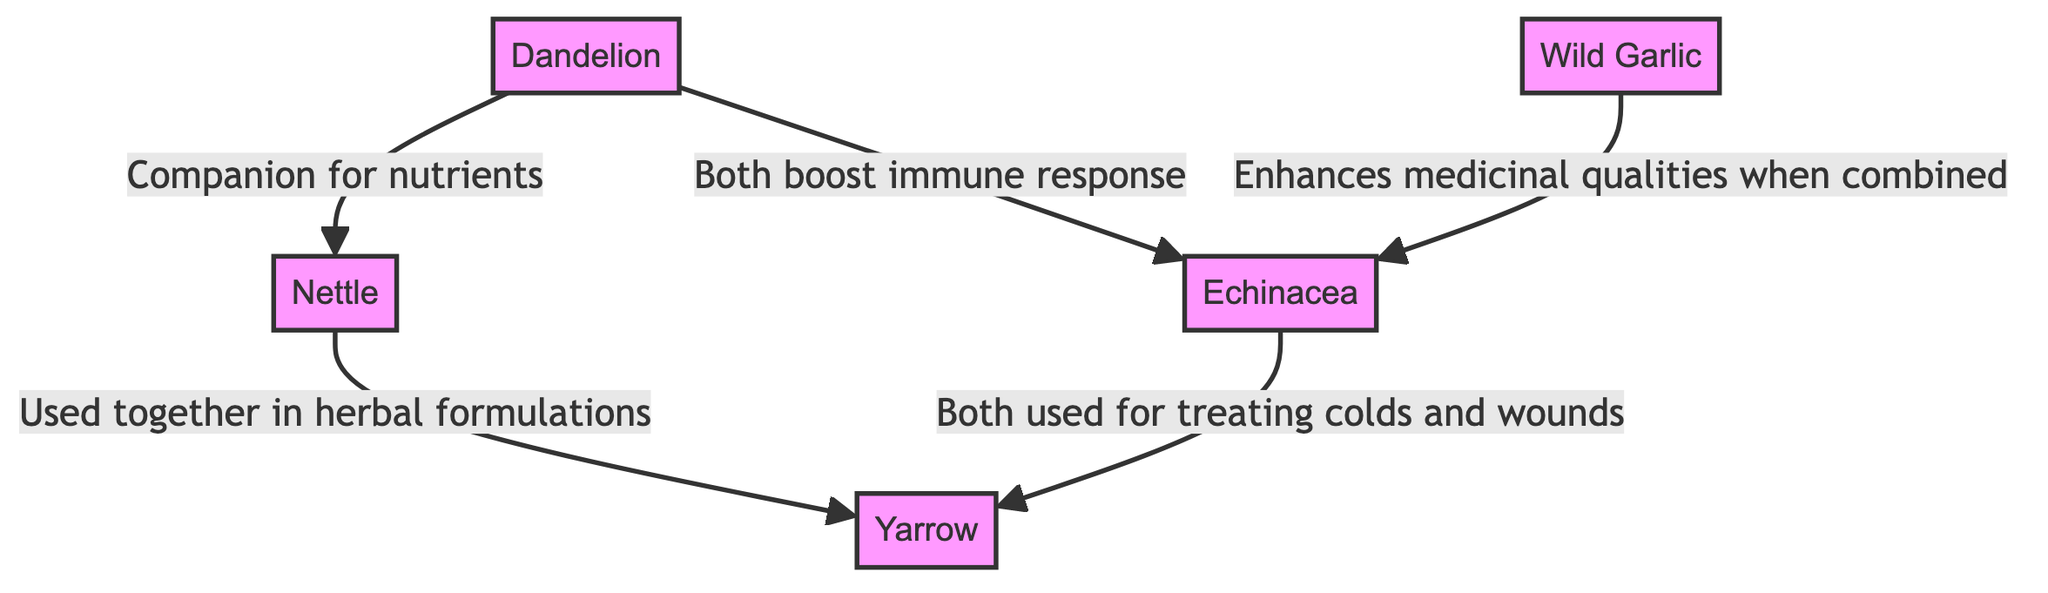What is the total number of nodes in the diagram? The diagram lists five distinct wild edibles: Dandelion, Nettle, Echinacea, Yarrow, and Wild Garlic. Counting these, the total number of nodes is 5.
Answer: 5 What is the relationship between Dandelion and Nettle? The diagram indicates that Dandelion is a companion for Nettle, specifically stating, "Companion for nutrients and soil health." This clarifies their relationship directly as described in the directed graph.
Answer: Companion for nutrients and soil health Which two plants are used together in herbal formulations? According to the diagram, Nettle and Yarrow are indicated to be used together in herbal formulations, as specified by the edge connecting them.
Answer: Nettle and Yarrow How many edges connect to Echinacea? By examining the directed edges, Echinacea connects to Yarrow and Wild Garlic, which totals to two edges leading from Echinacea to other nodes.
Answer: 2 What is a common use of both Echinacea and Yarrow? The diagram indicates that both Echinacea and Yarrow are used for treating colds and wounds, establishing their common medicinal use.
Answer: Treating colds and wounds Which wild edible enhances the medicinal qualities of Echinacea? The directed graph reveals that Wild Garlic enhances the medicinal qualities of Echinacea when combined, demonstrated by the edge leading from Wild Garlic to Echinacea.
Answer: Wild Garlic What type of relationship exists between Dandelion and Echinacea? The graph specifies the relationship as "Both boost immune response," indicating a synergistic relationship in terms of immune support between Dandelion and Echinacea.
Answer: Both boost immune response How many relationships involve Yarrow? Yarrow is involved in two relationships in the diagram: one with Nettle and one with Echinacea, showing its connections to both for different medicinal uses.
Answer: 2 